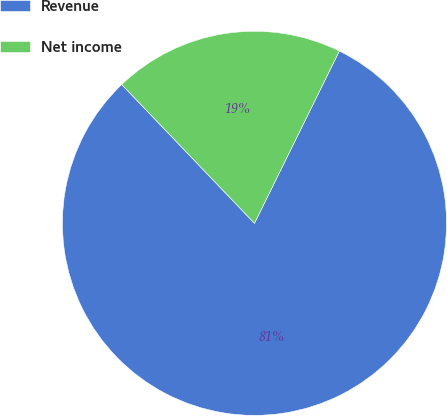<chart> <loc_0><loc_0><loc_500><loc_500><pie_chart><fcel>Revenue<fcel>Net income<nl><fcel>80.57%<fcel>19.43%<nl></chart> 